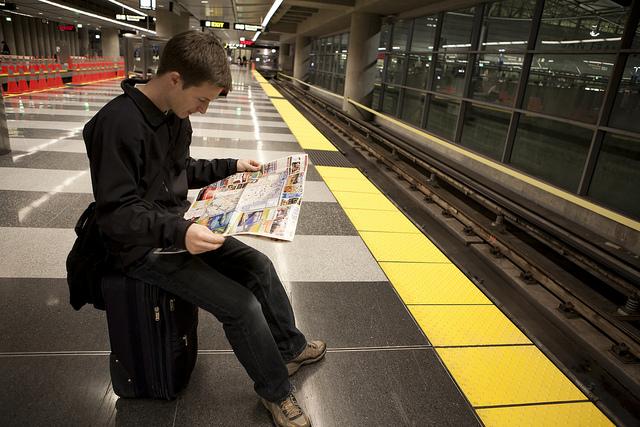What is the man   doing?
Quick response, please. Reading. What is the man sitting on?
Keep it brief. Suitcase. Where is the man sitting?
Answer briefly. Suitcase. 